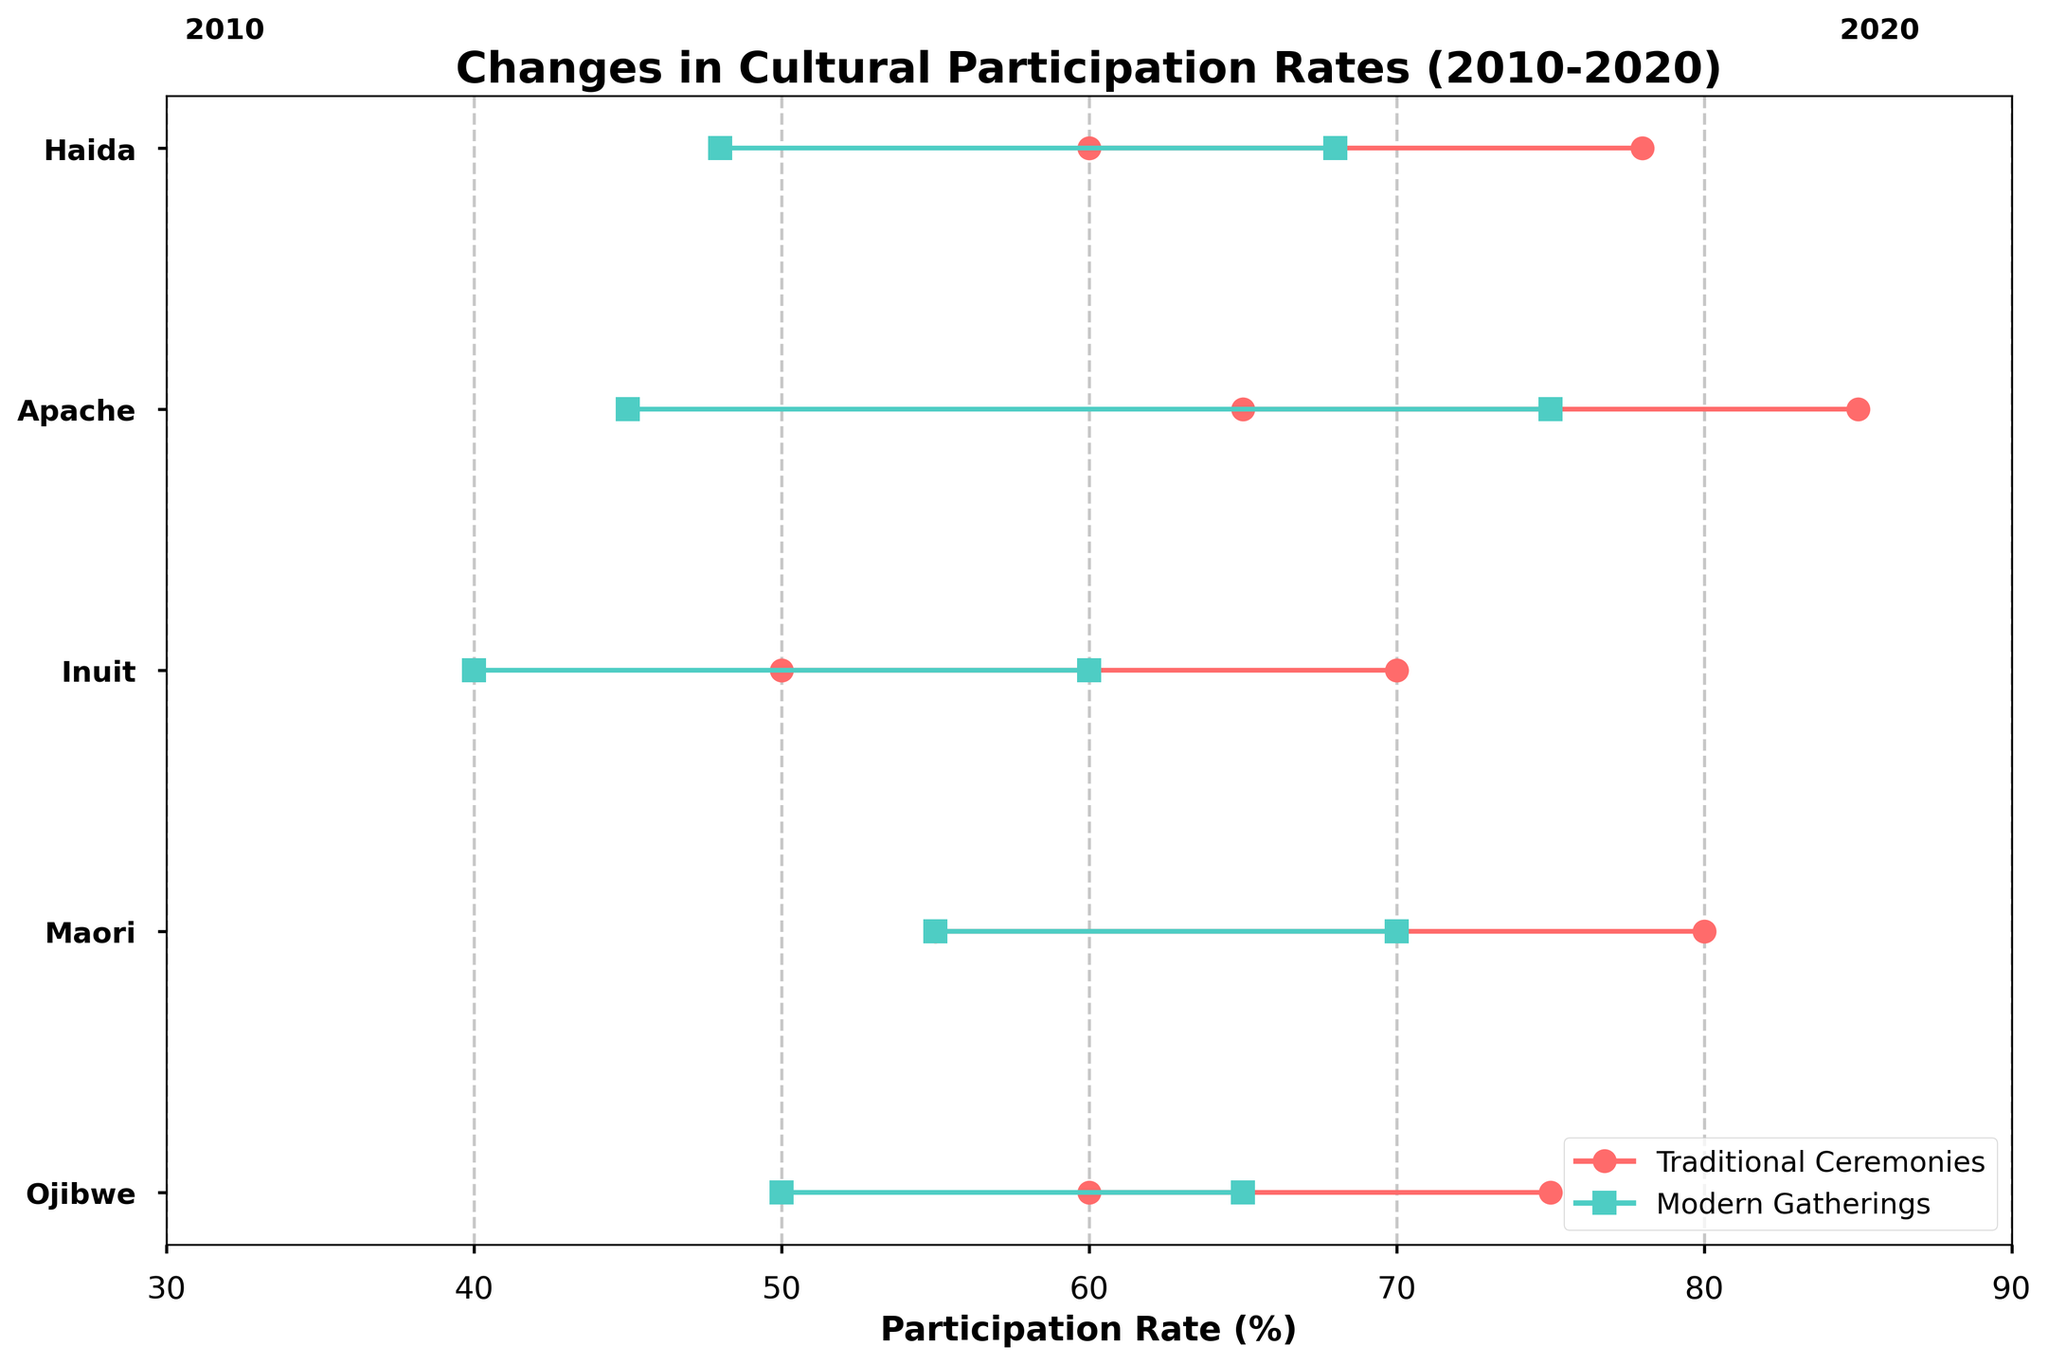What's the title of the plot? The title of a plot is typically the biggest text at the top, providing a brief description of what the plot represents. Here, the title is clearly written at the top of the figure.
Answer: Changes in Cultural Participation Rates (2010-2020) What is the participation rate in traditional ceremonies for the Apache culture in 2020? To find this, look at the line segment representing traditional ceremonies for the Apache culture. It is denoted by circles and the numerical axis at the bottom can tell the exact participation rate. The circle marker aligns with 65 on the x-axis.
Answer: 65 Which culture shows the largest decrease in traditional ceremonies participation rates from 2010 to 2020? Identify the largest gap between the 2010 and 2020 markers for traditional ceremonies participation for each culture. Measure the differences for all cultures and select the one with the highest value. The decreases are: Ojibwe (15), Maori (25), Inuit (20), Apache (20), Haida (18). The largest is Maori.
Answer: Maori In 2020, which culture has the highest participation rate in modern gatherings? Look along the bottom axis for the modern gatherings markers for 2020 (denoted by squares). Compare their positions to see which one is highest. Apache is at 75, which is the highest.
Answer: Apache What is the difference between the 2010 and 2020 participation rates in modern gatherings for the Inuit culture? Find the modern gatherings markers for the Inuit culture under 2010 and 2020. Calculate the difference between these two points: 60 (in 2020) - 40 (in 2010).
Answer: 20 How many cultures have a higher participation rate in modern gatherings than in traditional ceremonies in 2020? Compare the traditional ceremonies and modern gatherings rates for each culture in 2020. Count how many cultures have the modern gatherings rate greater than the traditional ceremonies rate. All cultures (Ojibwe, Maori, Inuit, Apache, Haida) exhibit this pattern.
Answer: 5 What trend is observed for traditional ceremonies participation rates from 2010 to 2020 across the cultures? Examine the positions of the traditional ceremonies markers from 2010 and 2020 across all cultures. Notice the trend, which is a decrease in each case.
Answer: Decrease Which culture had the smallest change in participation rates for traditional ceremonies between 2010 to 2020? Calculate the changes for all cultures: Ojibwe (15), Maori (25), Inuit (20), Apache (20), Haida (18). The smallest change is for Ojibwe.
Answer: Ojibwe What are the participation rates in modern gatherings for the Maori culture in 2010 and 2020, and what is the change? Locate the participation rates for Maori in 2010 and 2020 for modern gatherings. In 2010 it's 55 and in 2020 it's 70. Calculate the change: 70 - 55.
Answer: 15 For which culture does the participation rate in traditional ceremonies remain above 60% in both 2010 and 2020? Check the traditional ceremonies rates for all cultures in both years. Only Apache remains above 60% in both years: 85 (2010) and 65 (2020).
Answer: Apache 